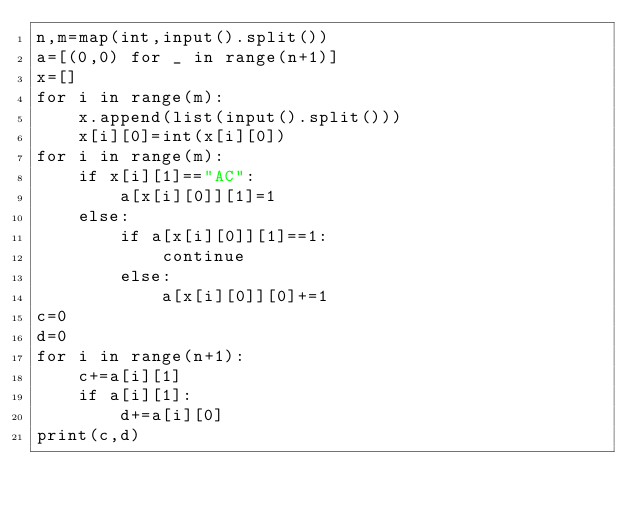Convert code to text. <code><loc_0><loc_0><loc_500><loc_500><_Python_>n,m=map(int,input().split())
a=[(0,0) for _ in range(n+1)]
x=[]
for i in range(m):
    x.append(list(input().split()))
    x[i][0]=int(x[i][0])
for i in range(m):
    if x[i][1]=="AC":
        a[x[i][0]][1]=1
    else:
        if a[x[i][0]][1]==1:
            continue
        else:
            a[x[i][0]][0]+=1
c=0
d=0
for i in range(n+1):
    c+=a[i][1]
    if a[i][1]:
        d+=a[i][0]
print(c,d)</code> 